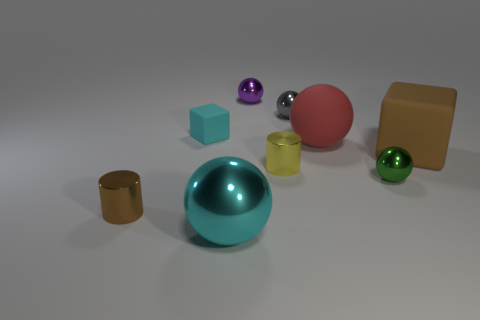Subtract all small shiny balls. How many balls are left? 2 Subtract all brown blocks. How many blocks are left? 1 Subtract all brown spheres. Subtract all blue cylinders. How many spheres are left? 5 Subtract all tiny metal spheres. Subtract all blue things. How many objects are left? 6 Add 8 small brown cylinders. How many small brown cylinders are left? 9 Add 2 purple blocks. How many purple blocks exist? 2 Subtract 0 blue spheres. How many objects are left? 9 Subtract all balls. How many objects are left? 4 Subtract 4 spheres. How many spheres are left? 1 